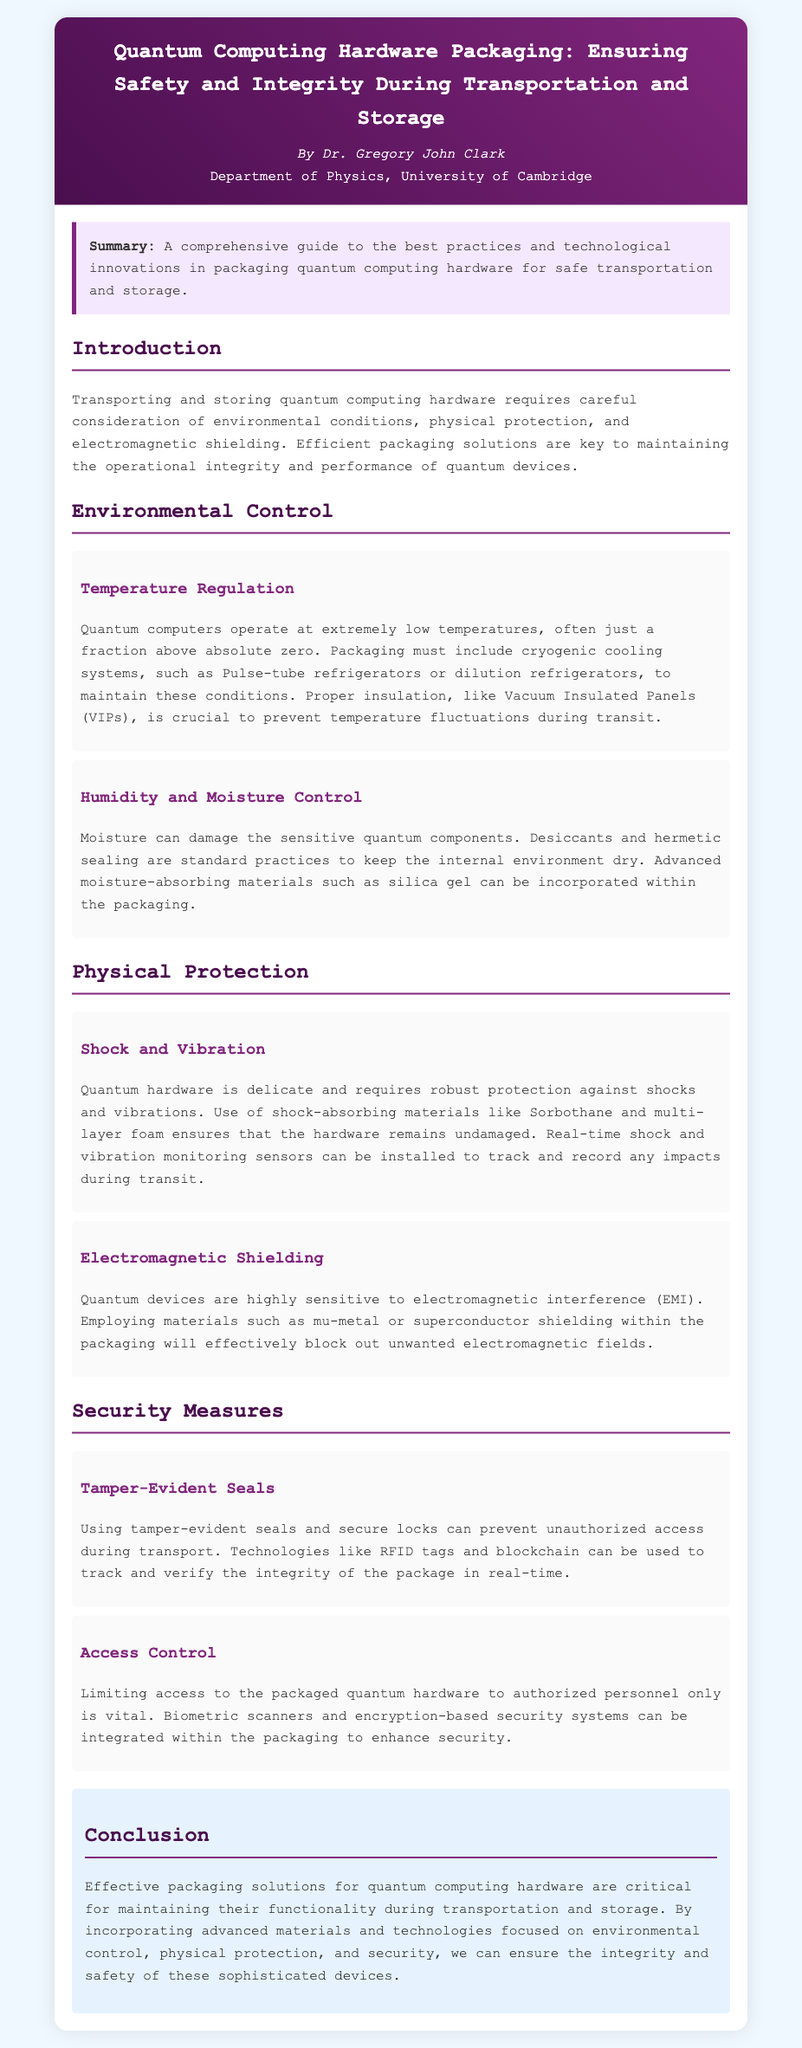What is the main focus of the document? The document is a comprehensive guide to packaging quantum computing hardware, emphasizing safety and integrity during transportation and storage.
Answer: Packaging quantum computing hardware Who is the author of the document? The document attributes the authorship to Dr. Gregory John Clark.
Answer: Dr. Gregory John Clark What temperature regulation systems are mentioned? Pulse-tube refrigerators and dilution refrigerators are specified for temperature regulation.
Answer: Pulse-tube refrigerators or dilution refrigerators What materials are suggested for moisture control? The document mentions desiccants and advanced moisture-absorbing materials like silica gel for moisture control.
Answer: Desiccants and silica gel What is the role of mu-metal in packaging? Mu-metal serves as a material for electromagnetic shielding to block unwanted electromagnetic fields.
Answer: Electromagnetic shielding Why is shock-absorbing material important? Shock-absorbing material like Sorbothane is crucial for protecting delicate quantum hardware from shocks and vibrations.
Answer: Protecting delicate quantum hardware What technology can be used to track package integrity? RFID tags and blockchain technologies are mentioned for tracking package integrity.
Answer: RFID tags and blockchain What security measure is used to prevent unauthorized access? Tamper-evident seals are recommended as a security measure against unauthorized access.
Answer: Tamper-evident seals What is the objective of the document’s conclusion? The conclusion summarizes the importance of effective packaging solutions for maintaining functionality during transportation.
Answer: Maintaining functionality during transportation 